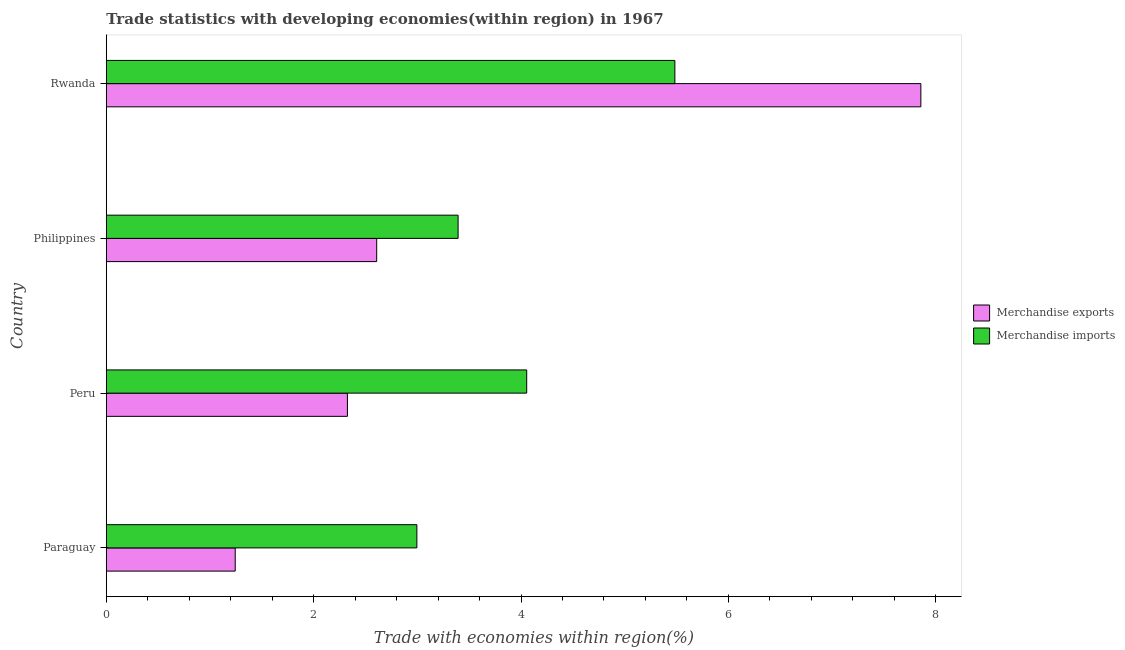Are the number of bars on each tick of the Y-axis equal?
Provide a short and direct response. Yes. How many bars are there on the 4th tick from the top?
Provide a short and direct response. 2. How many bars are there on the 4th tick from the bottom?
Your answer should be compact. 2. What is the label of the 2nd group of bars from the top?
Provide a short and direct response. Philippines. In how many cases, is the number of bars for a given country not equal to the number of legend labels?
Provide a succinct answer. 0. What is the merchandise imports in Rwanda?
Keep it short and to the point. 5.48. Across all countries, what is the maximum merchandise exports?
Provide a short and direct response. 7.86. Across all countries, what is the minimum merchandise imports?
Make the answer very short. 3. In which country was the merchandise imports maximum?
Your response must be concise. Rwanda. In which country was the merchandise exports minimum?
Provide a succinct answer. Paraguay. What is the total merchandise exports in the graph?
Give a very brief answer. 14.03. What is the difference between the merchandise imports in Paraguay and that in Rwanda?
Your response must be concise. -2.49. What is the difference between the merchandise exports in Paraguay and the merchandise imports in Rwanda?
Offer a terse response. -4.24. What is the average merchandise imports per country?
Make the answer very short. 3.98. What is the difference between the merchandise imports and merchandise exports in Philippines?
Your answer should be compact. 0.79. In how many countries, is the merchandise imports greater than 7.2 %?
Your answer should be very brief. 0. What is the ratio of the merchandise exports in Paraguay to that in Rwanda?
Provide a short and direct response. 0.16. Is the merchandise exports in Peru less than that in Rwanda?
Offer a terse response. Yes. Is the difference between the merchandise exports in Philippines and Rwanda greater than the difference between the merchandise imports in Philippines and Rwanda?
Your response must be concise. No. What is the difference between the highest and the second highest merchandise exports?
Provide a succinct answer. 5.25. What is the difference between the highest and the lowest merchandise exports?
Ensure brevity in your answer.  6.61. What does the 1st bar from the bottom in Peru represents?
Ensure brevity in your answer.  Merchandise exports. How many bars are there?
Provide a succinct answer. 8. Are all the bars in the graph horizontal?
Give a very brief answer. Yes. How many legend labels are there?
Provide a short and direct response. 2. What is the title of the graph?
Give a very brief answer. Trade statistics with developing economies(within region) in 1967. Does "Taxes on profits and capital gains" appear as one of the legend labels in the graph?
Make the answer very short. No. What is the label or title of the X-axis?
Provide a short and direct response. Trade with economies within region(%). What is the label or title of the Y-axis?
Ensure brevity in your answer.  Country. What is the Trade with economies within region(%) of Merchandise exports in Paraguay?
Offer a very short reply. 1.24. What is the Trade with economies within region(%) of Merchandise imports in Paraguay?
Provide a succinct answer. 3. What is the Trade with economies within region(%) in Merchandise exports in Peru?
Ensure brevity in your answer.  2.33. What is the Trade with economies within region(%) of Merchandise imports in Peru?
Provide a succinct answer. 4.05. What is the Trade with economies within region(%) in Merchandise exports in Philippines?
Provide a succinct answer. 2.61. What is the Trade with economies within region(%) of Merchandise imports in Philippines?
Ensure brevity in your answer.  3.39. What is the Trade with economies within region(%) in Merchandise exports in Rwanda?
Provide a short and direct response. 7.86. What is the Trade with economies within region(%) in Merchandise imports in Rwanda?
Provide a short and direct response. 5.48. Across all countries, what is the maximum Trade with economies within region(%) of Merchandise exports?
Your answer should be compact. 7.86. Across all countries, what is the maximum Trade with economies within region(%) of Merchandise imports?
Offer a very short reply. 5.48. Across all countries, what is the minimum Trade with economies within region(%) of Merchandise exports?
Your response must be concise. 1.24. Across all countries, what is the minimum Trade with economies within region(%) in Merchandise imports?
Your answer should be very brief. 3. What is the total Trade with economies within region(%) of Merchandise exports in the graph?
Give a very brief answer. 14.03. What is the total Trade with economies within region(%) of Merchandise imports in the graph?
Your response must be concise. 15.93. What is the difference between the Trade with economies within region(%) of Merchandise exports in Paraguay and that in Peru?
Give a very brief answer. -1.08. What is the difference between the Trade with economies within region(%) in Merchandise imports in Paraguay and that in Peru?
Your answer should be very brief. -1.06. What is the difference between the Trade with economies within region(%) in Merchandise exports in Paraguay and that in Philippines?
Make the answer very short. -1.36. What is the difference between the Trade with economies within region(%) of Merchandise imports in Paraguay and that in Philippines?
Offer a very short reply. -0.4. What is the difference between the Trade with economies within region(%) of Merchandise exports in Paraguay and that in Rwanda?
Your response must be concise. -6.61. What is the difference between the Trade with economies within region(%) of Merchandise imports in Paraguay and that in Rwanda?
Your response must be concise. -2.49. What is the difference between the Trade with economies within region(%) in Merchandise exports in Peru and that in Philippines?
Your answer should be very brief. -0.28. What is the difference between the Trade with economies within region(%) of Merchandise imports in Peru and that in Philippines?
Make the answer very short. 0.66. What is the difference between the Trade with economies within region(%) in Merchandise exports in Peru and that in Rwanda?
Ensure brevity in your answer.  -5.53. What is the difference between the Trade with economies within region(%) of Merchandise imports in Peru and that in Rwanda?
Give a very brief answer. -1.43. What is the difference between the Trade with economies within region(%) of Merchandise exports in Philippines and that in Rwanda?
Provide a short and direct response. -5.25. What is the difference between the Trade with economies within region(%) of Merchandise imports in Philippines and that in Rwanda?
Ensure brevity in your answer.  -2.09. What is the difference between the Trade with economies within region(%) of Merchandise exports in Paraguay and the Trade with economies within region(%) of Merchandise imports in Peru?
Give a very brief answer. -2.81. What is the difference between the Trade with economies within region(%) of Merchandise exports in Paraguay and the Trade with economies within region(%) of Merchandise imports in Philippines?
Your answer should be compact. -2.15. What is the difference between the Trade with economies within region(%) of Merchandise exports in Paraguay and the Trade with economies within region(%) of Merchandise imports in Rwanda?
Provide a short and direct response. -4.24. What is the difference between the Trade with economies within region(%) of Merchandise exports in Peru and the Trade with economies within region(%) of Merchandise imports in Philippines?
Your response must be concise. -1.07. What is the difference between the Trade with economies within region(%) in Merchandise exports in Peru and the Trade with economies within region(%) in Merchandise imports in Rwanda?
Your answer should be compact. -3.16. What is the difference between the Trade with economies within region(%) of Merchandise exports in Philippines and the Trade with economies within region(%) of Merchandise imports in Rwanda?
Make the answer very short. -2.88. What is the average Trade with economies within region(%) of Merchandise exports per country?
Ensure brevity in your answer.  3.51. What is the average Trade with economies within region(%) of Merchandise imports per country?
Provide a short and direct response. 3.98. What is the difference between the Trade with economies within region(%) in Merchandise exports and Trade with economies within region(%) in Merchandise imports in Paraguay?
Ensure brevity in your answer.  -1.75. What is the difference between the Trade with economies within region(%) in Merchandise exports and Trade with economies within region(%) in Merchandise imports in Peru?
Give a very brief answer. -1.73. What is the difference between the Trade with economies within region(%) in Merchandise exports and Trade with economies within region(%) in Merchandise imports in Philippines?
Provide a short and direct response. -0.79. What is the difference between the Trade with economies within region(%) of Merchandise exports and Trade with economies within region(%) of Merchandise imports in Rwanda?
Keep it short and to the point. 2.37. What is the ratio of the Trade with economies within region(%) of Merchandise exports in Paraguay to that in Peru?
Make the answer very short. 0.53. What is the ratio of the Trade with economies within region(%) in Merchandise imports in Paraguay to that in Peru?
Give a very brief answer. 0.74. What is the ratio of the Trade with economies within region(%) of Merchandise exports in Paraguay to that in Philippines?
Your response must be concise. 0.48. What is the ratio of the Trade with economies within region(%) of Merchandise imports in Paraguay to that in Philippines?
Your answer should be very brief. 0.88. What is the ratio of the Trade with economies within region(%) in Merchandise exports in Paraguay to that in Rwanda?
Keep it short and to the point. 0.16. What is the ratio of the Trade with economies within region(%) in Merchandise imports in Paraguay to that in Rwanda?
Ensure brevity in your answer.  0.55. What is the ratio of the Trade with economies within region(%) in Merchandise exports in Peru to that in Philippines?
Give a very brief answer. 0.89. What is the ratio of the Trade with economies within region(%) in Merchandise imports in Peru to that in Philippines?
Provide a short and direct response. 1.2. What is the ratio of the Trade with economies within region(%) in Merchandise exports in Peru to that in Rwanda?
Offer a terse response. 0.3. What is the ratio of the Trade with economies within region(%) in Merchandise imports in Peru to that in Rwanda?
Your answer should be very brief. 0.74. What is the ratio of the Trade with economies within region(%) in Merchandise exports in Philippines to that in Rwanda?
Your response must be concise. 0.33. What is the ratio of the Trade with economies within region(%) of Merchandise imports in Philippines to that in Rwanda?
Provide a succinct answer. 0.62. What is the difference between the highest and the second highest Trade with economies within region(%) of Merchandise exports?
Offer a terse response. 5.25. What is the difference between the highest and the second highest Trade with economies within region(%) of Merchandise imports?
Your answer should be very brief. 1.43. What is the difference between the highest and the lowest Trade with economies within region(%) of Merchandise exports?
Offer a very short reply. 6.61. What is the difference between the highest and the lowest Trade with economies within region(%) of Merchandise imports?
Provide a succinct answer. 2.49. 